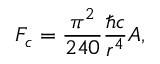<formula> <loc_0><loc_0><loc_500><loc_500>F _ { c } = \frac { \pi ^ { 2 } } { 2 4 0 } \frac { \hbar { c } } { r ^ { 4 } } A ,</formula> 